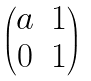<formula> <loc_0><loc_0><loc_500><loc_500>\begin{pmatrix} a & 1 \\ 0 & 1 \end{pmatrix}</formula> 